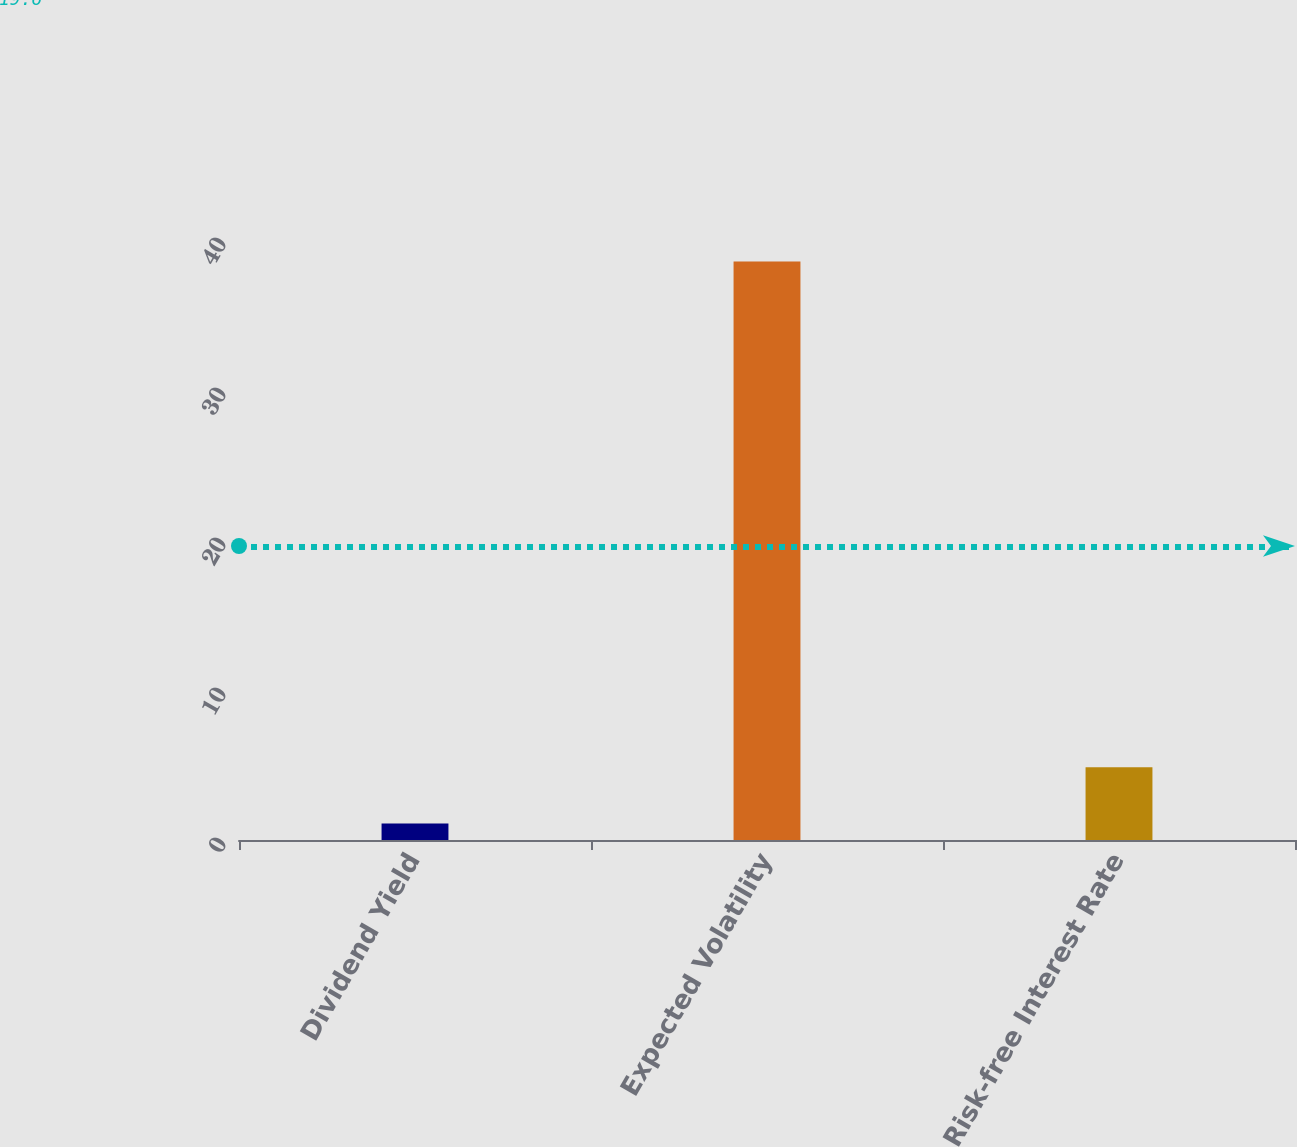Convert chart to OTSL. <chart><loc_0><loc_0><loc_500><loc_500><bar_chart><fcel>Dividend Yield<fcel>Expected Volatility<fcel>Risk-free Interest Rate<nl><fcel>1.1<fcel>38.56<fcel>4.85<nl></chart> 